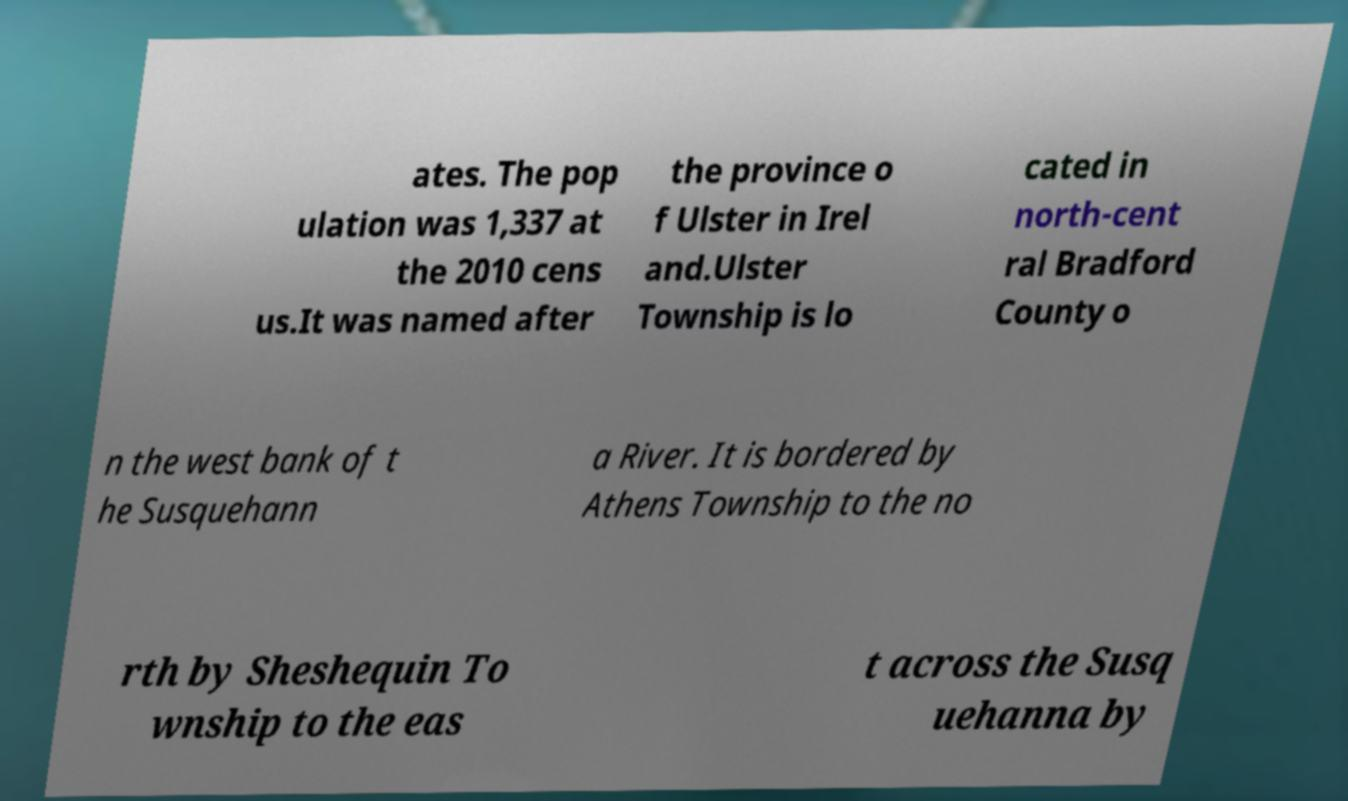What messages or text are displayed in this image? I need them in a readable, typed format. ates. The pop ulation was 1,337 at the 2010 cens us.It was named after the province o f Ulster in Irel and.Ulster Township is lo cated in north-cent ral Bradford County o n the west bank of t he Susquehann a River. It is bordered by Athens Township to the no rth by Sheshequin To wnship to the eas t across the Susq uehanna by 